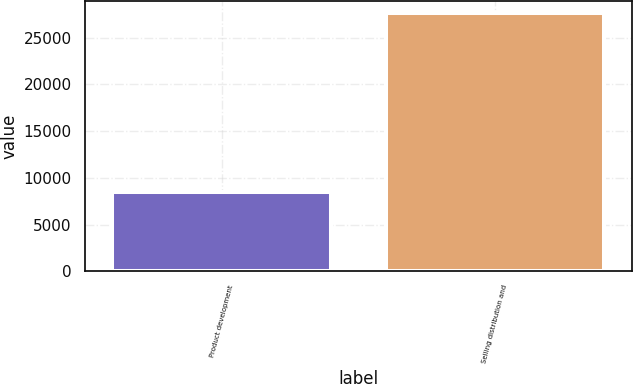<chart> <loc_0><loc_0><loc_500><loc_500><bar_chart><fcel>Product development<fcel>Selling distribution and<nl><fcel>8470<fcel>27576<nl></chart> 